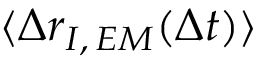<formula> <loc_0><loc_0><loc_500><loc_500>\langle \Delta r _ { I , \, E M } ( \Delta t ) \rangle</formula> 